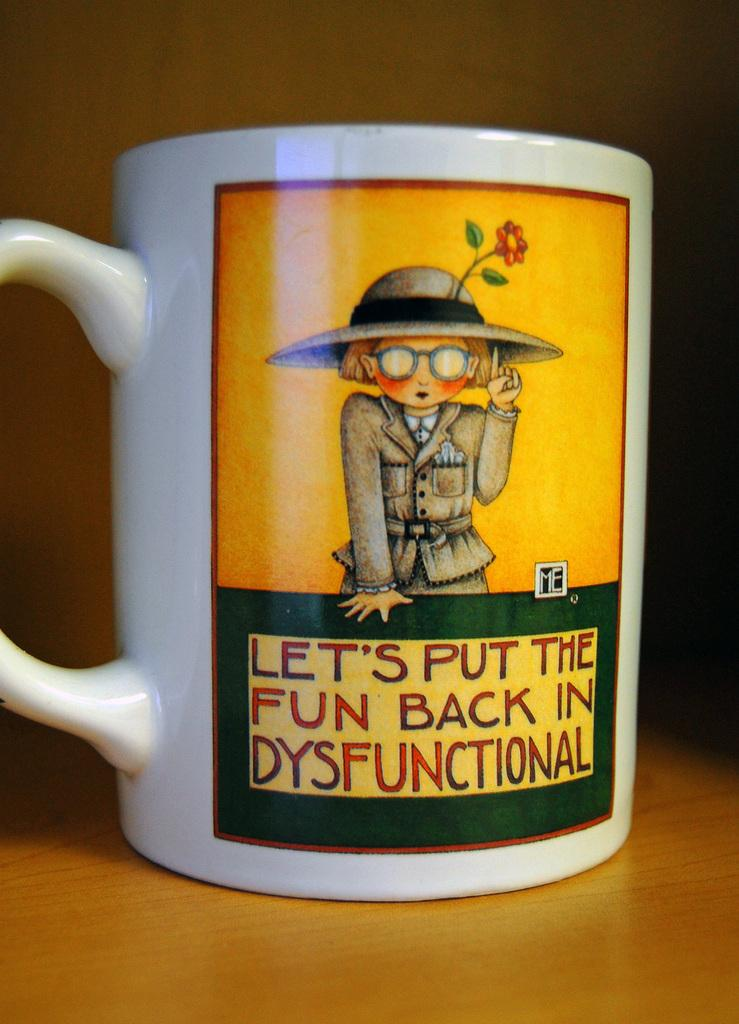Provide a one-sentence caption for the provided image. A mug saying to put fun back in dysfunctional. 